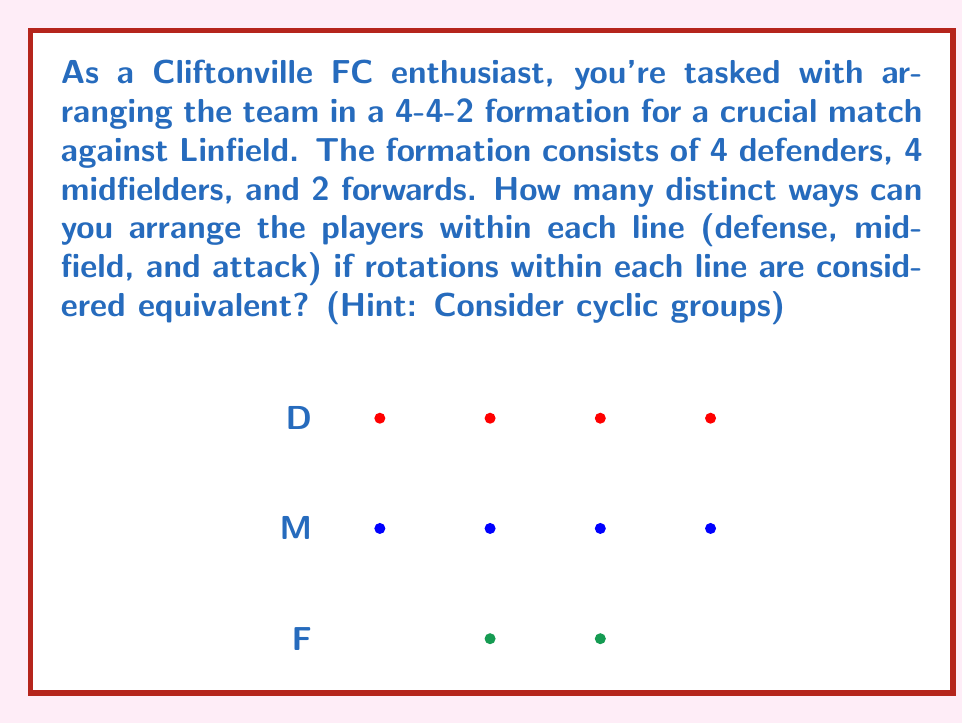Could you help me with this problem? Let's approach this step-by-step using cyclic groups:

1) For the defenders (4 players):
   - The cyclic group $C_4$ represents rotations of 4 elements.
   - The number of distinct arrangements is $4!/4 = 3!= 6$.

2) For the midfielders (4 players):
   - Similarly, we have $4!/4 = 3! = 6$ distinct arrangements.

3) For the forwards (2 players):
   - The cyclic group $C_2$ represents rotations of 2 elements.
   - The number of distinct arrangements is $2!/2 = 1$.

4) By the multiplication principle, the total number of distinct arrangements is:

   $$6 \times 6 \times 1 = 36$$

Explanation using group theory:

- For $n$ elements, the cyclic group $C_n$ has order $n$.
- The number of distinct arrangements under cyclic rotations is $n!/n = (n-1)!$.
- This is because out of $n!$ total permutations, $n$ of them are considered equivalent under rotation.

Therefore, for each line of players, we divide the total number of permutations by the order of the corresponding cyclic group to get the number of distinct arrangements under rotation.
Answer: 36 